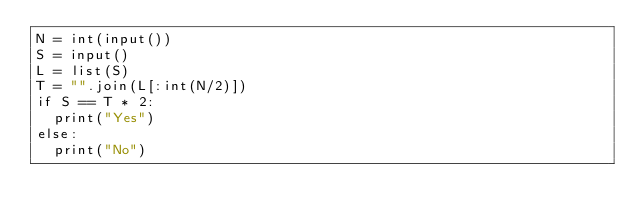<code> <loc_0><loc_0><loc_500><loc_500><_Python_>N = int(input())
S = input()
L = list(S)
T = "".join(L[:int(N/2)])
if S == T * 2:
  print("Yes")
else:
  print("No")</code> 